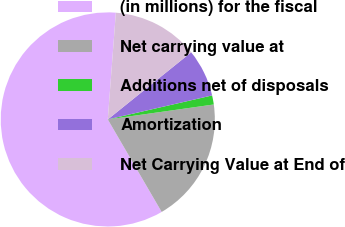Convert chart. <chart><loc_0><loc_0><loc_500><loc_500><pie_chart><fcel>(in millions) for the fiscal<fcel>Net carrying value at<fcel>Additions net of disposals<fcel>Amortization<fcel>Net Carrying Value at End of<nl><fcel>59.6%<fcel>18.84%<fcel>1.37%<fcel>7.19%<fcel>13.01%<nl></chart> 